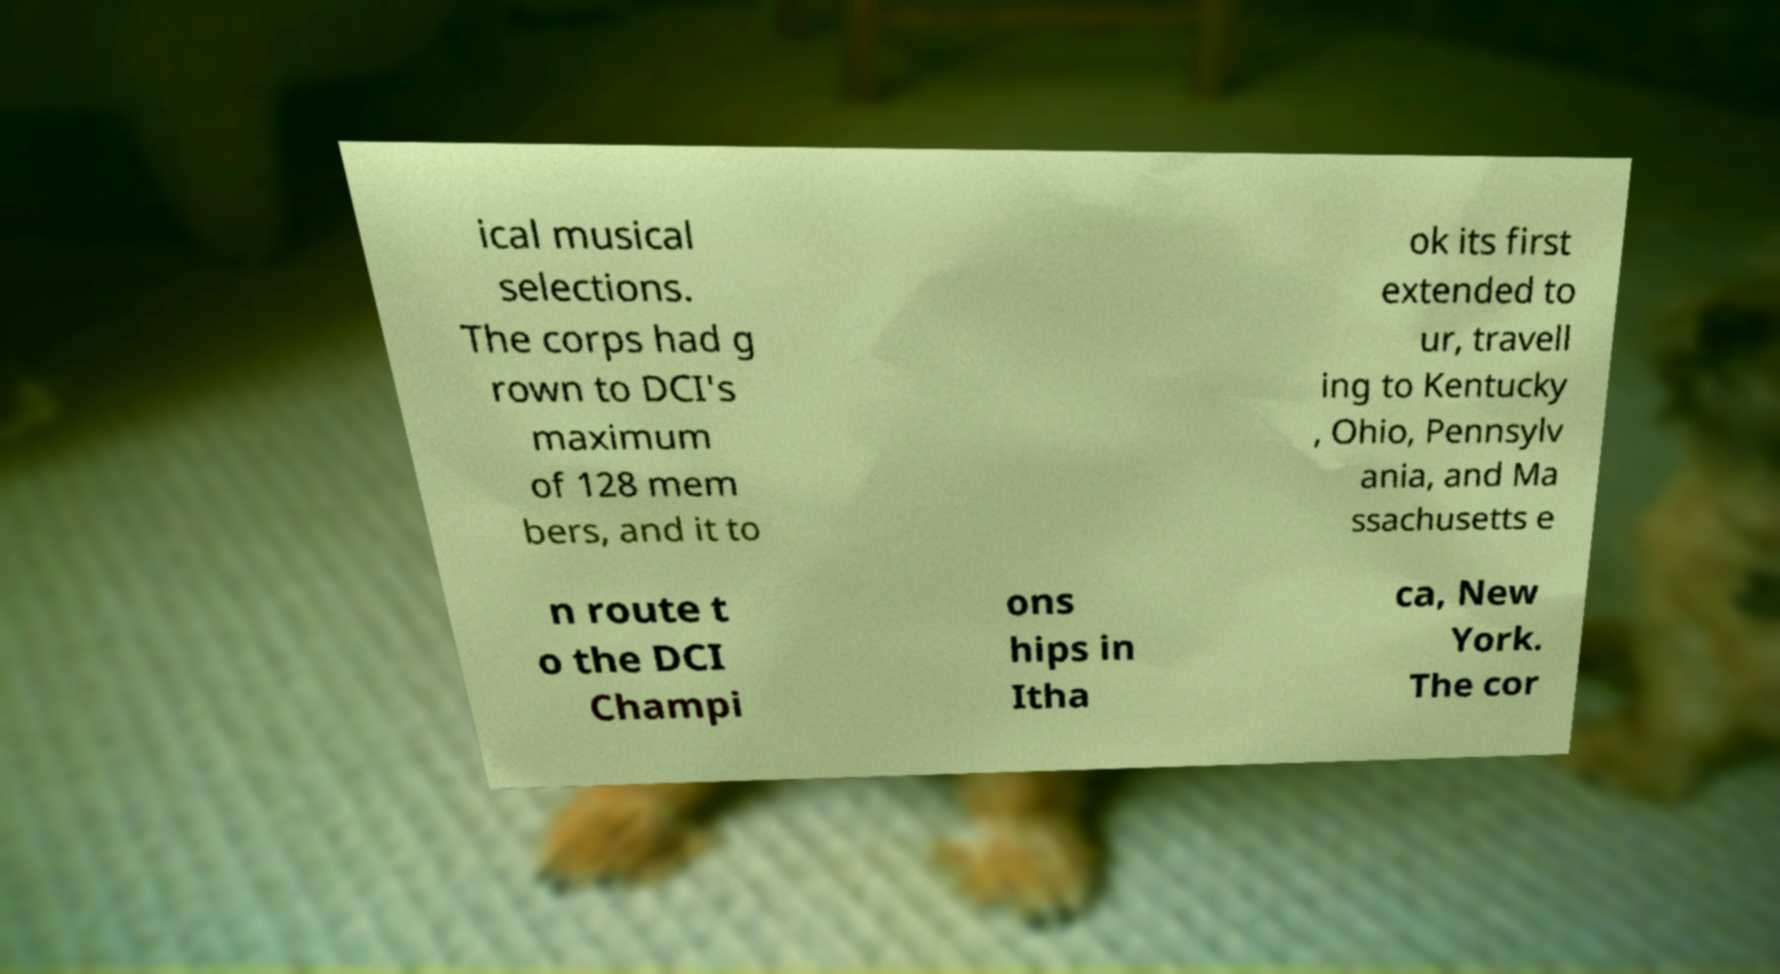What messages or text are displayed in this image? I need them in a readable, typed format. ical musical selections. The corps had g rown to DCI's maximum of 128 mem bers, and it to ok its first extended to ur, travell ing to Kentucky , Ohio, Pennsylv ania, and Ma ssachusetts e n route t o the DCI Champi ons hips in Itha ca, New York. The cor 